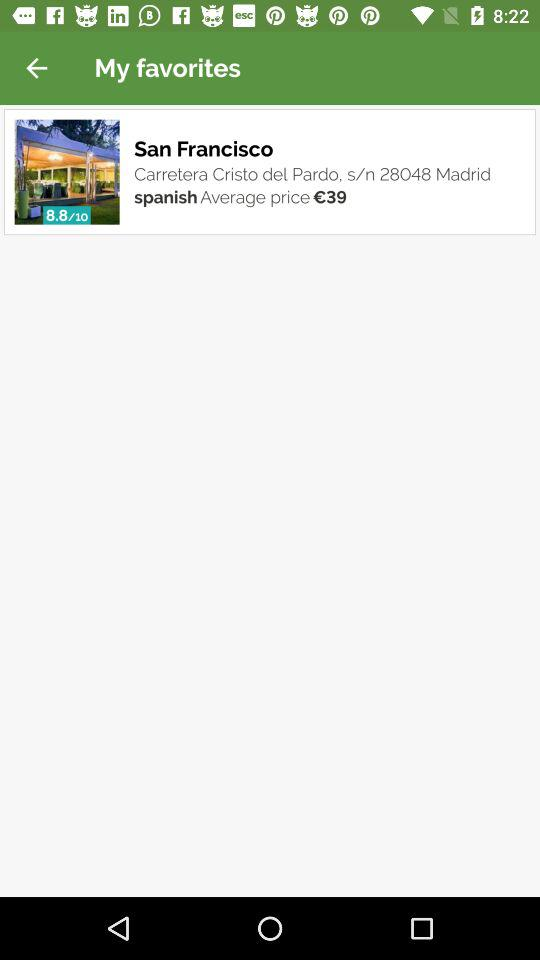How many ratings has San Francisco got? The San Francisco has an 8.8 ratings. 